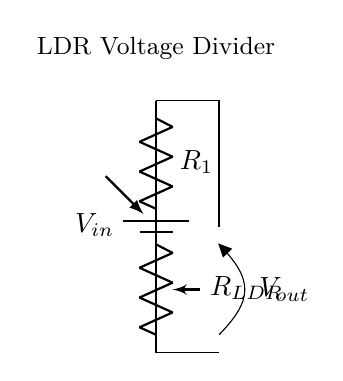What is the voltage source in this circuit? The voltage source is indicated by the battery symbol, labeled as Vin. It provides the input voltage for the entire circuit.
Answer: Vin What component acts as a variable resistor in this circuit? The light-dependent resistor, labeled as R_LDR, changes its resistance based on the light intensity. This makes it the variable resistor in the circuit.
Answer: R_LDR What is the function of the fixed resistor in this circuit? The fixed resistor, labeled as R1, is part of the voltage divider. It helps set the voltage drop across the LDR relative to the input voltage.
Answer: Voltage division What does V_out represent in this circuit? V_out is the output voltage measured across the light-dependent resistor. It varies based on the resistance of the LDR and the current flowing through the circuit.
Answer: Output voltage How does light intensity affect the output voltage in this LDR circuit? As light intensity increases, the resistance of the LDR decreases, causing a larger portion of Vin to drop across R1, which results in an increase in V_out. Conversely, with lower light intensity, the resistance of the LDR increases, lowering V_out.
Answer: Inversely proportional What type of circuit configuration does this diagram represent? This circuit represents a voltage divider configuration where the LDR and fixed resistor are in series, allowing for a divided voltage output.
Answer: Voltage divider 